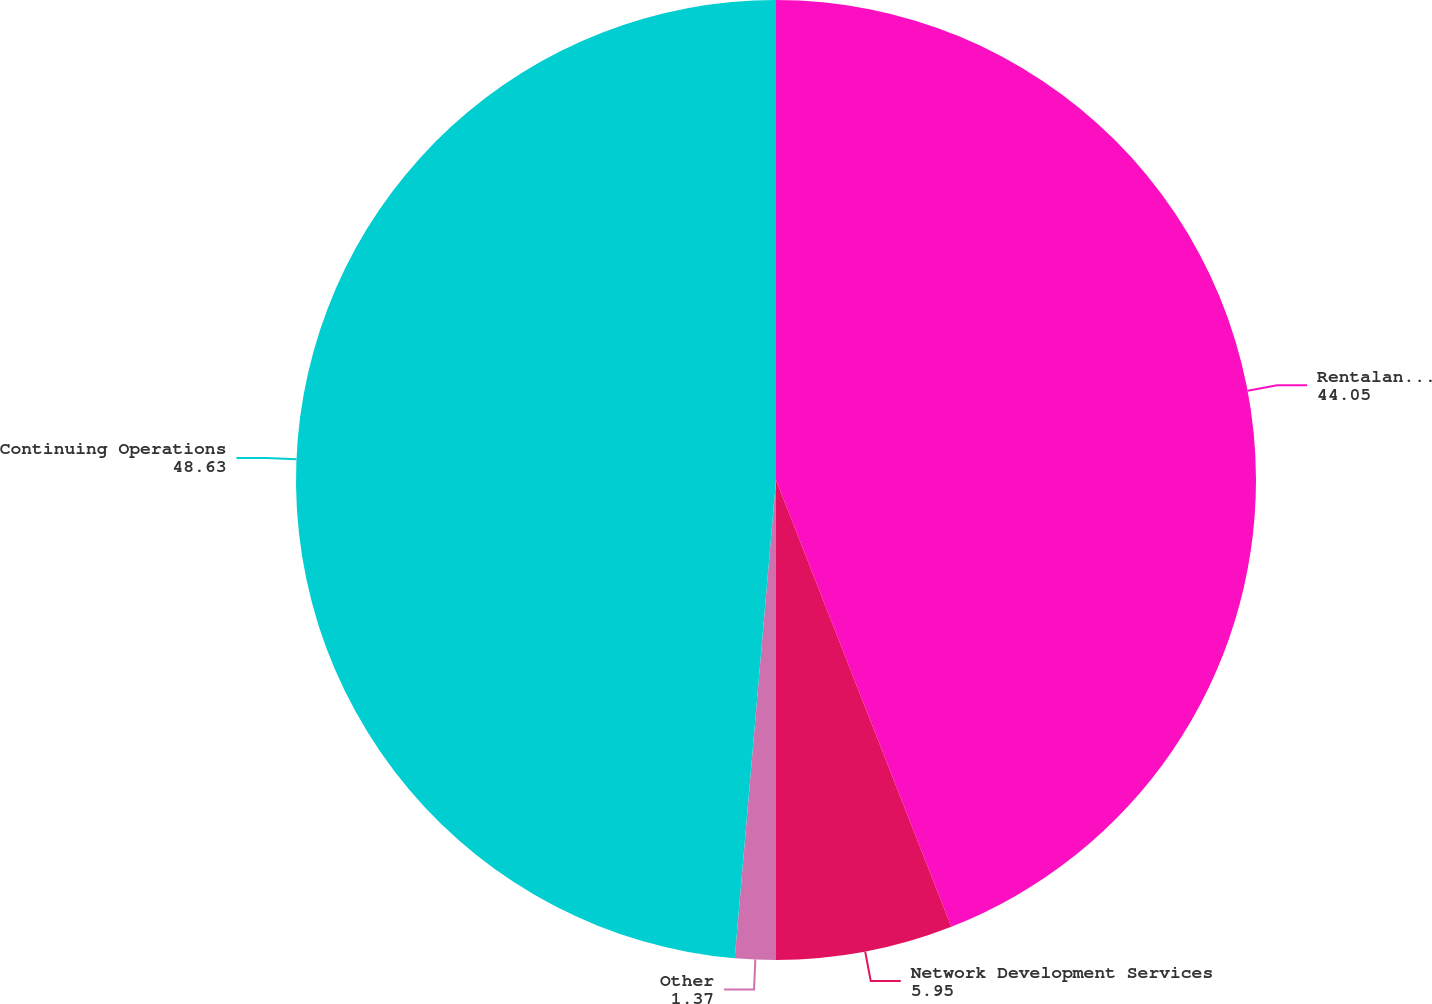Convert chart. <chart><loc_0><loc_0><loc_500><loc_500><pie_chart><fcel>RentalandManagement<fcel>Network Development Services<fcel>Other<fcel>Continuing Operations<nl><fcel>44.05%<fcel>5.95%<fcel>1.37%<fcel>48.63%<nl></chart> 